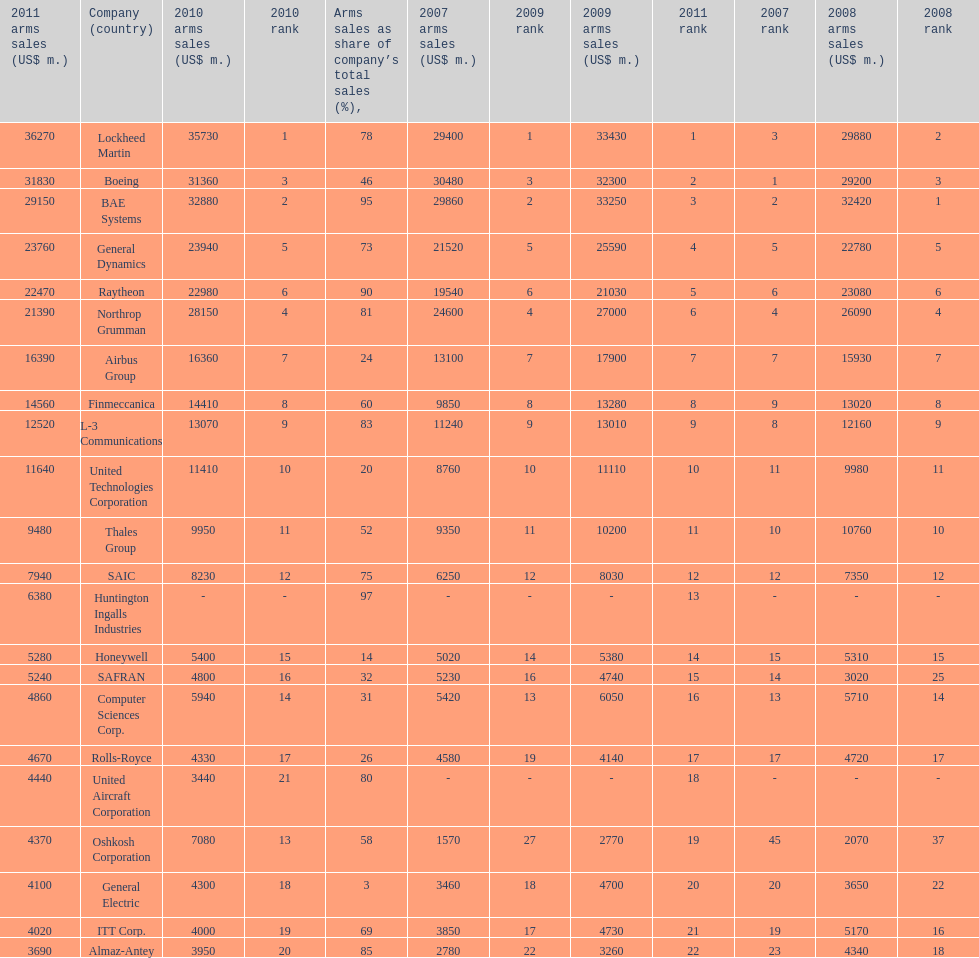What country is the first listed country? USA. 